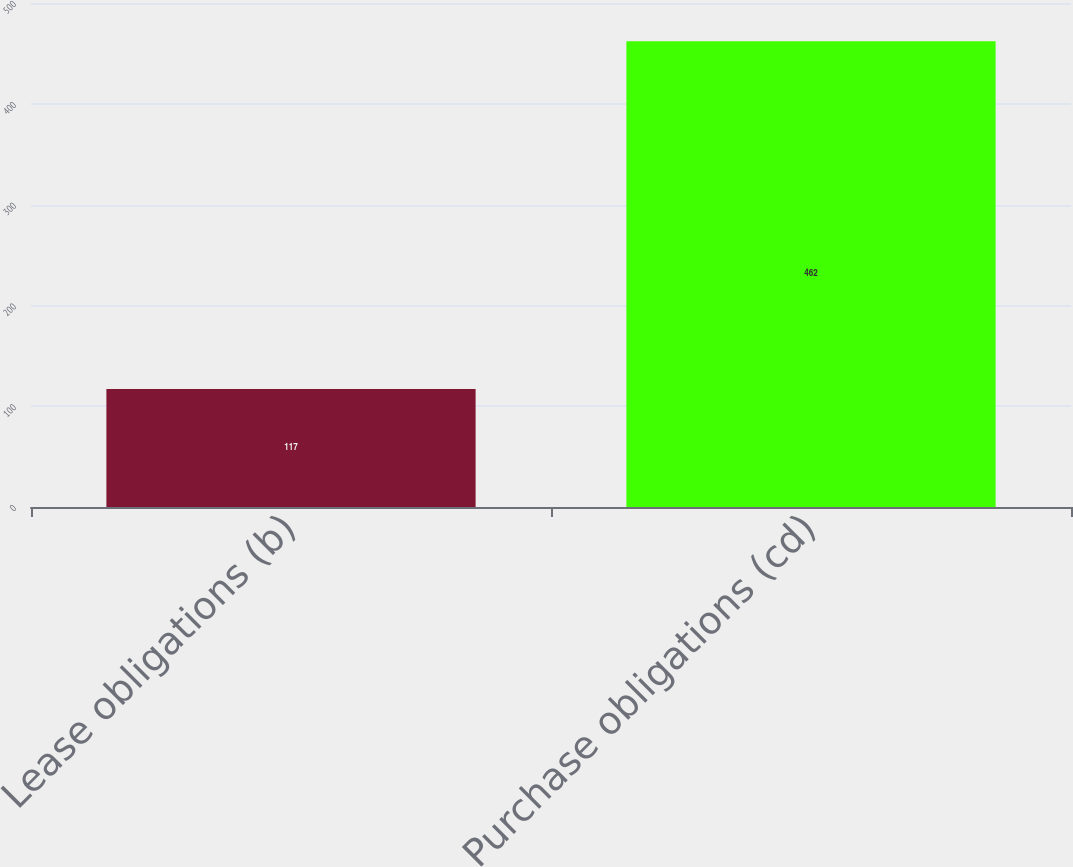Convert chart. <chart><loc_0><loc_0><loc_500><loc_500><bar_chart><fcel>Lease obligations (b)<fcel>Purchase obligations (cd)<nl><fcel>117<fcel>462<nl></chart> 